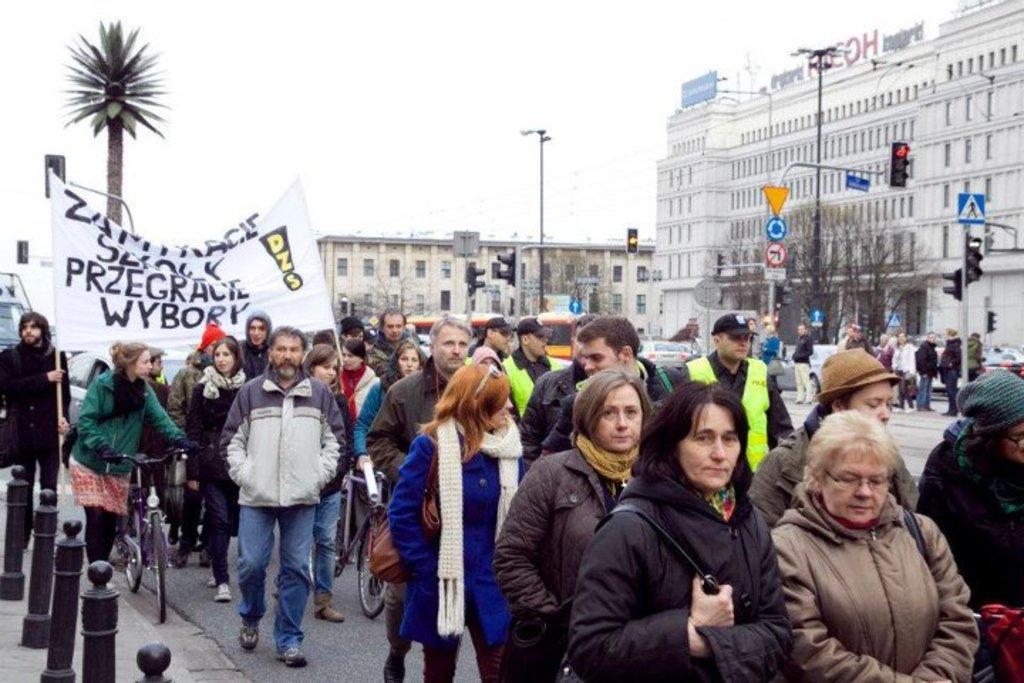Describe this image in one or two sentences. On the left side, there are poles on a footpath. On the right side, there are persons in different color dresses on the road. Some of them are holding bicycles. Some of the rest are holding a banner. In the background, there are vehicles, trees, persons, buildings and the sky. 